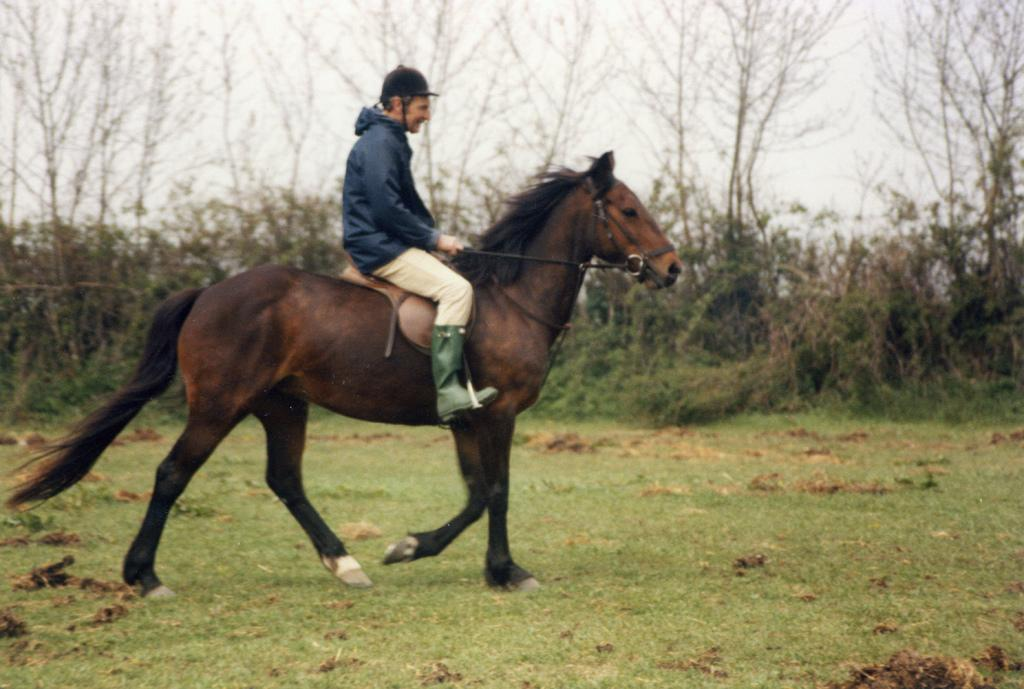Who is the main subject in the image? There is a man in the image. What is the man doing in the image? The man is riding a horse. What can be seen in the background of the image? There are trees in the background of the image. What type of beetle can be seen crawling on the man's shoulder in the image? There is no beetle present on the man's shoulder in the image. 